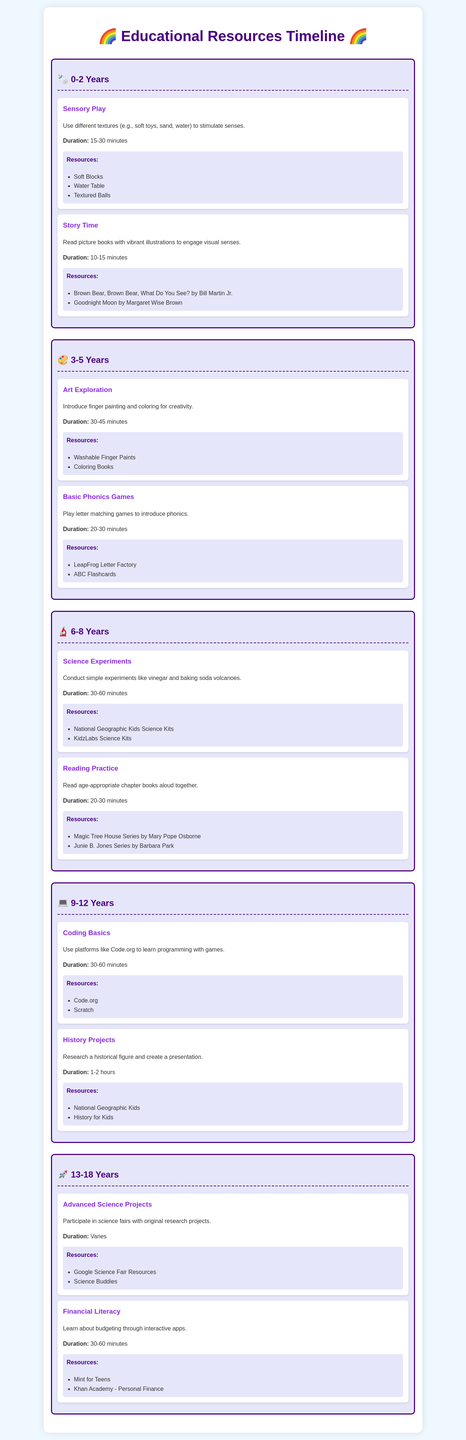What age group is focused on Sensory Play? Sensory Play is an activity listed under the age group 0-2 Years.
Answer: 0-2 Years What is one resource for Basic Phonics Games? Basic Phonics Games includes a resource called ABC Flashcards.
Answer: ABC Flashcards What is the duration of Art Exploration activities? Art Exploration activities are designed to last 30-45 minutes.
Answer: 30-45 minutes How many resources are listed for Reading Practice? Reading Practice has two resources mentioned in the document.
Answer: Two What educational area does Coding Basics belong to? Coding Basics is an activity for the age group 9-12 Years.
Answer: 9-12 Years What type of activity is included for ages 13-18 Years? Advanced Science Projects is an example of an activity for ages 13-18 Years.
Answer: Advanced Science Projects Which book is recommended for Story Time? One of the recommended books for Story Time is Goodnight Moon.
Answer: Goodnight Moon How long should History Projects take to complete? History Projects should take about 1-2 hours to complete.
Answer: 1-2 hours What is the main subject of Financial Literacy? Financial Literacy focuses on learning about budgeting.
Answer: Budgeting 